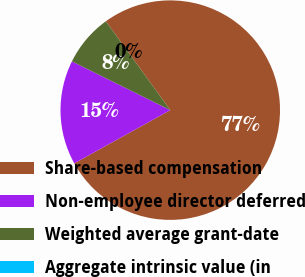Convert chart to OTSL. <chart><loc_0><loc_0><loc_500><loc_500><pie_chart><fcel>Share-based compensation<fcel>Non-employee director deferred<fcel>Weighted average grant-date<fcel>Aggregate intrinsic value (in<nl><fcel>76.92%<fcel>15.38%<fcel>7.69%<fcel>0.0%<nl></chart> 